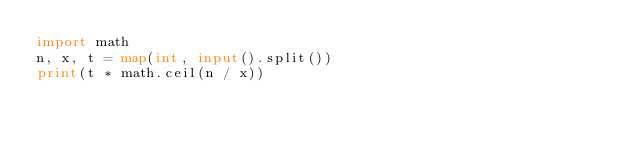Convert code to text. <code><loc_0><loc_0><loc_500><loc_500><_Python_>import math
n, x, t = map(int, input().split())
print(t * math.ceil(n / x))</code> 